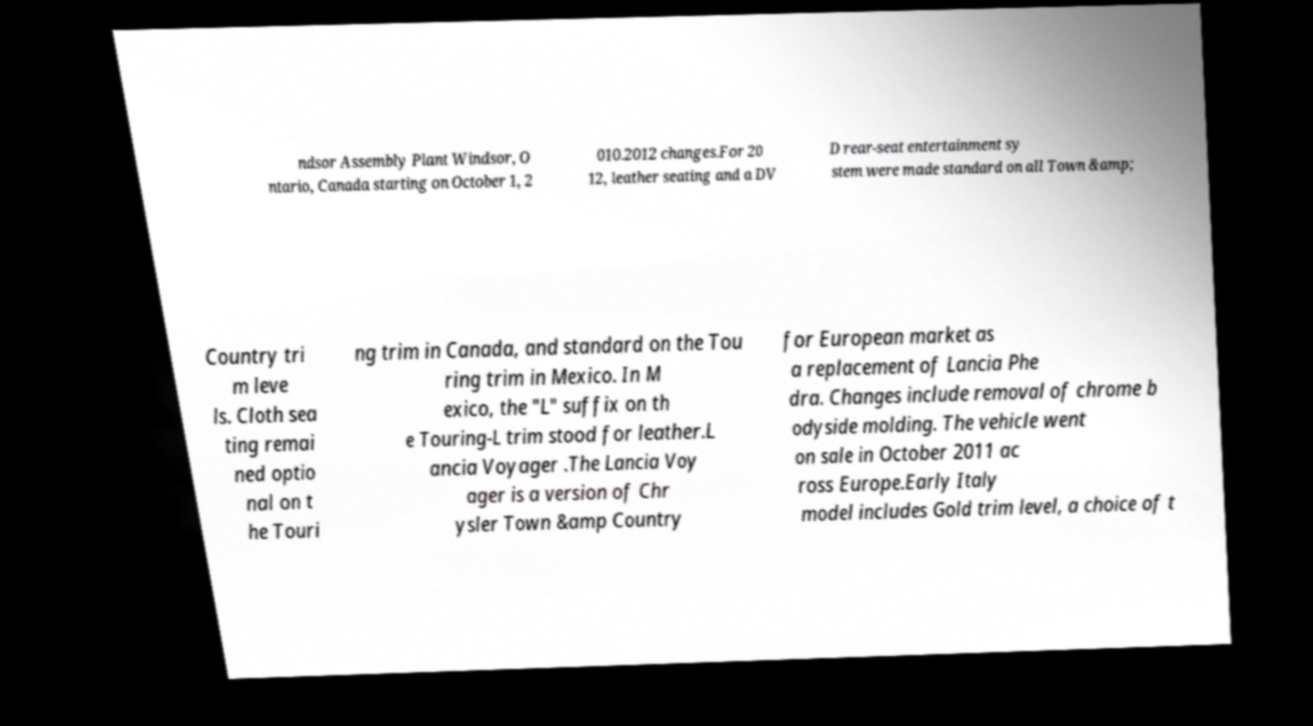What messages or text are displayed in this image? I need them in a readable, typed format. ndsor Assembly Plant Windsor, O ntario, Canada starting on October 1, 2 010.2012 changes.For 20 12, leather seating and a DV D rear-seat entertainment sy stem were made standard on all Town &amp; Country tri m leve ls. Cloth sea ting remai ned optio nal on t he Touri ng trim in Canada, and standard on the Tou ring trim in Mexico. In M exico, the "L" suffix on th e Touring-L trim stood for leather.L ancia Voyager .The Lancia Voy ager is a version of Chr ysler Town &amp Country for European market as a replacement of Lancia Phe dra. Changes include removal of chrome b odyside molding. The vehicle went on sale in October 2011 ac ross Europe.Early Italy model includes Gold trim level, a choice of t 